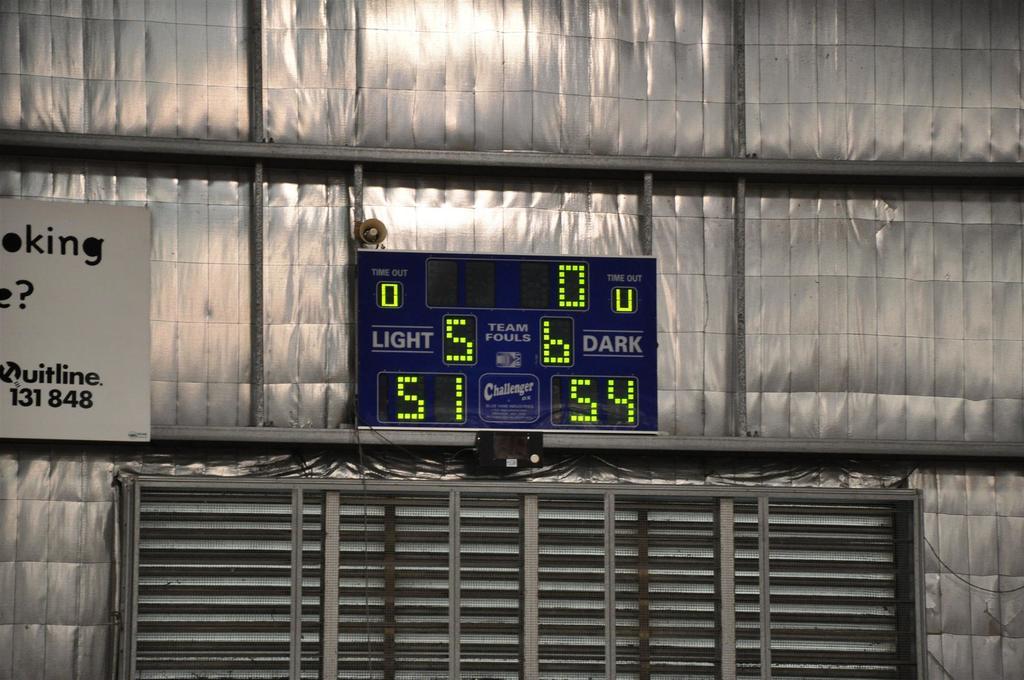How many fouls have the dark team commited?
Offer a terse response. 6. 